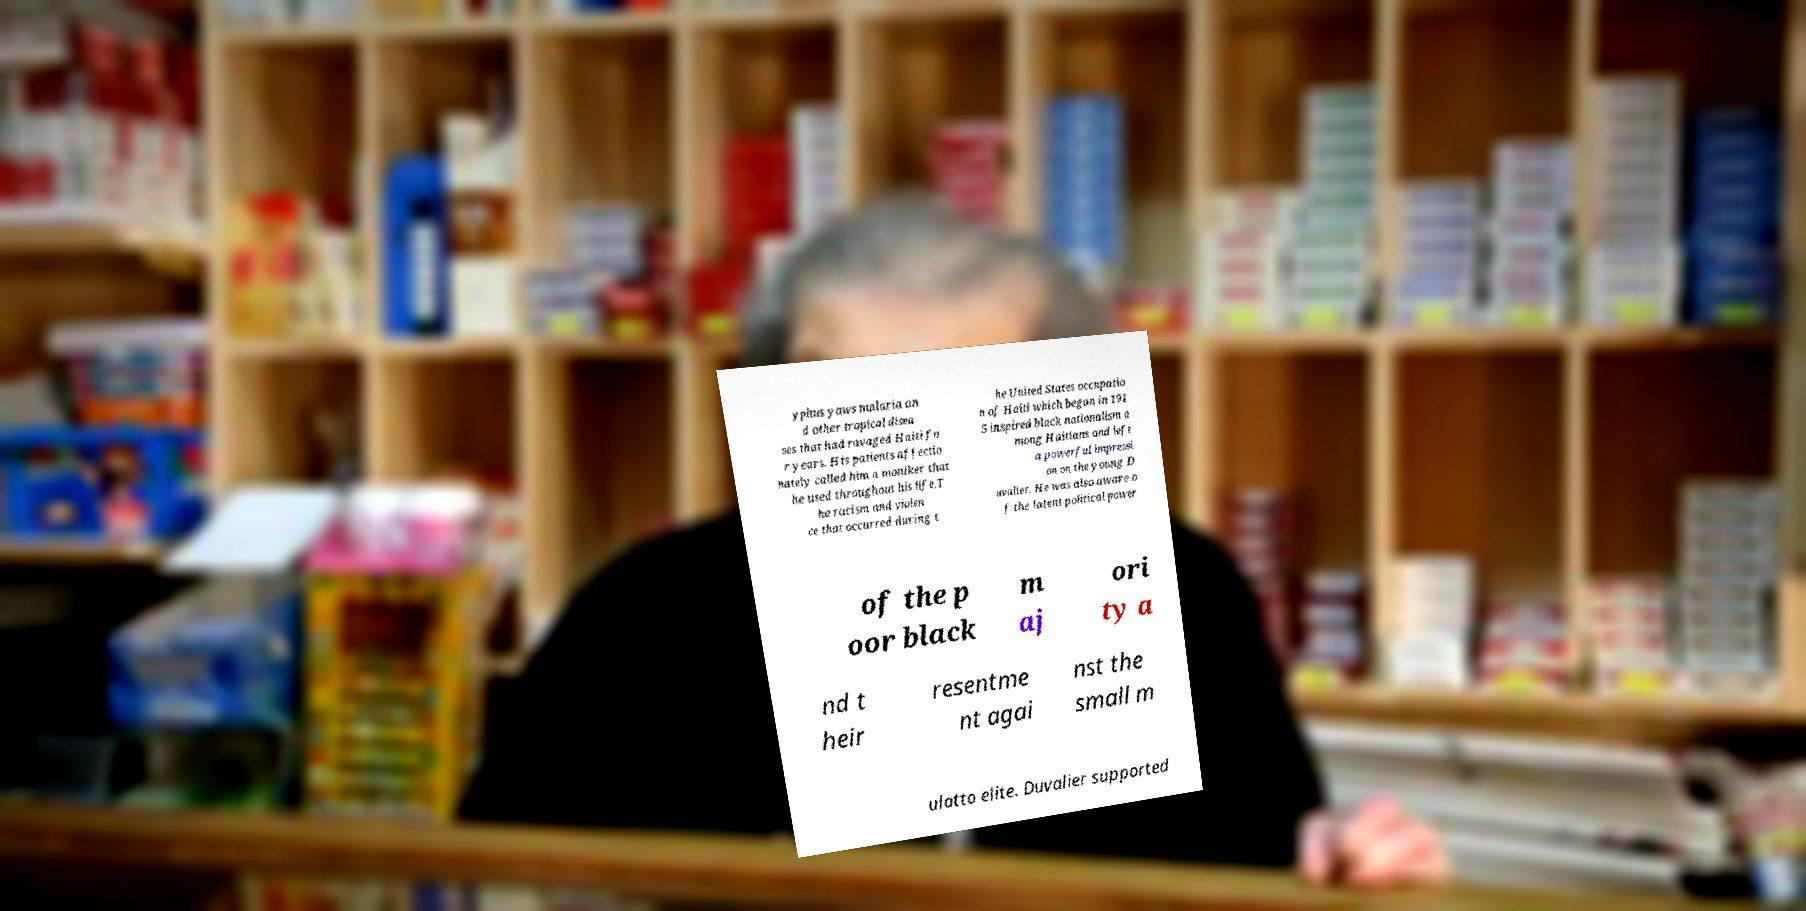There's text embedded in this image that I need extracted. Can you transcribe it verbatim? yphus yaws malaria an d other tropical disea ses that had ravaged Haiti fo r years. His patients affectio nately called him a moniker that he used throughout his life.T he racism and violen ce that occurred during t he United States occupatio n of Haiti which began in 191 5 inspired black nationalism a mong Haitians and left a powerful impressi on on the young D uvalier. He was also aware o f the latent political power of the p oor black m aj ori ty a nd t heir resentme nt agai nst the small m ulatto elite. Duvalier supported 